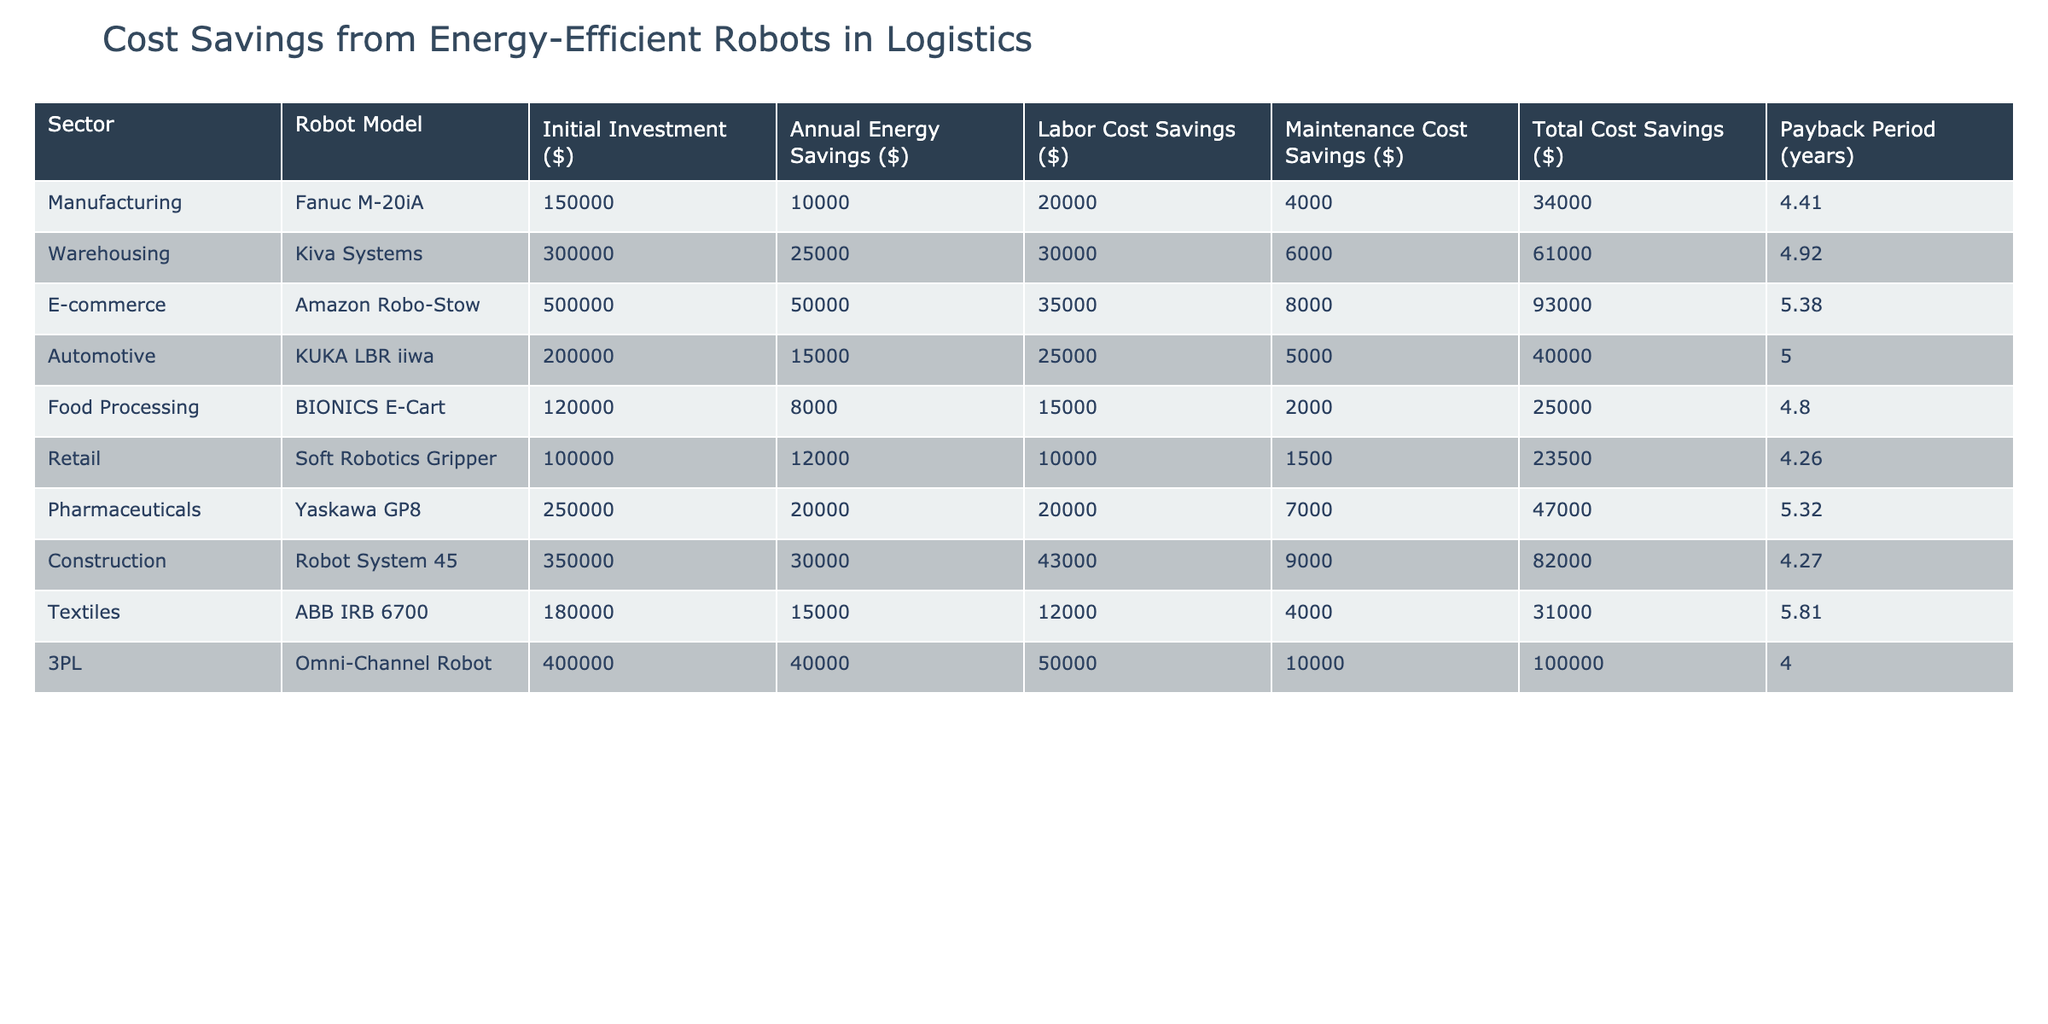What is the total cost savings for the Amazon Robo-Stow robot? By directly looking at the table, the total cost savings for the Amazon Robo-Stow robot is listed under the "Total Cost Savings ($)" column which is 93000.
Answer: 93000 Which robot model has the longest payback period? The payback period for each robot is listed under the "Payback Period (years)" column. Comparing these values, the robot with the longest payback period is the ABB IRB 6700 with a payback period of 5.81 years.
Answer: ABB IRB 6700 What is the sum of annual energy savings for all robots in the Food Processing and Retail sectors? From the table, the annual energy savings for the Food Processing robot (BIONICS E-Cart) is 8000 and for the Retail robot (Soft Robotics Gripper) it is 12000. Adding these gives 8000 + 12000 = 20000.
Answer: 20000 Is the initial investment for Kiva Systems more than that of the Fanuc M-20iA? The initial investment for Kiva Systems is 300000 while for Fanuc M-20iA it is 150000. Since 300000 > 150000, the statement is true.
Answer: Yes What is the average total cost savings across all robot models? To find the average total cost savings, we need to sum all the total cost savings values: 34000 + 61000 + 93000 + 40000 + 25000 + 23500 + 47000 + 82000 + 31000 + 100000 = 601000. There are 10 robot models, so the average is 601000 / 10 = 60100.
Answer: 60100 Which sector has the highest labor cost savings, and what is that amount? By reviewing the "Labor Cost Savings ($)" column, the Omni-Channel Robot in the 3PL sector has the highest labor cost savings of 50000.
Answer: 50000 If we combine the annual energy savings of the Automotive and Pharmaceuticals sectors, what is the resulting figure? The annual energy savings for the Automotive (KUKA LBR iiwa) is 15000 and for the Pharmaceuticals (Yaskawa GP8) it is 20000. Adding these gives us 15000 + 20000 = 35000.
Answer: 35000 Does the Food Processing sector have higher maintenance cost savings than the Retail sector? The maintenance cost savings for the Food Processing sector (BIONICS E-Cart) is 2000, and for the Retail sector (Soft Robotics Gripper) it is 1500. Since 2000 > 1500, the statement is true.
Answer: Yes What is the difference in total cost savings between the 3PL and Food Processing sectors? The total cost savings for the 3PL (Omni-Channel Robot) is 100000 and for Food Processing (BIONICS E-Cart) is 25000. Therefore, the difference is 100000 - 25000 = 75000.
Answer: 75000 